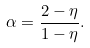Convert formula to latex. <formula><loc_0><loc_0><loc_500><loc_500>\alpha = \frac { 2 - \eta } { 1 - \eta } .</formula> 